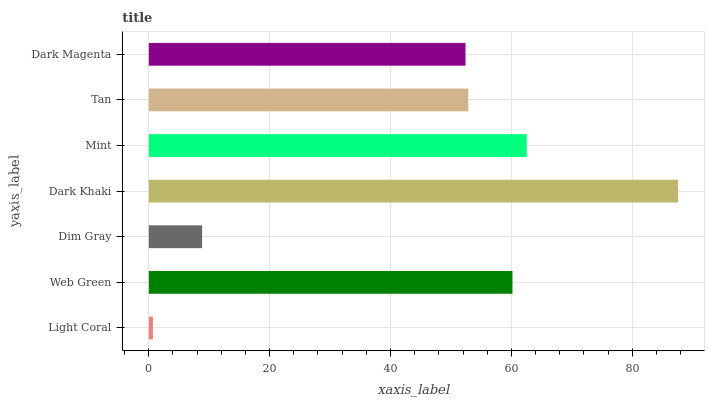Is Light Coral the minimum?
Answer yes or no. Yes. Is Dark Khaki the maximum?
Answer yes or no. Yes. Is Web Green the minimum?
Answer yes or no. No. Is Web Green the maximum?
Answer yes or no. No. Is Web Green greater than Light Coral?
Answer yes or no. Yes. Is Light Coral less than Web Green?
Answer yes or no. Yes. Is Light Coral greater than Web Green?
Answer yes or no. No. Is Web Green less than Light Coral?
Answer yes or no. No. Is Tan the high median?
Answer yes or no. Yes. Is Tan the low median?
Answer yes or no. Yes. Is Light Coral the high median?
Answer yes or no. No. Is Web Green the low median?
Answer yes or no. No. 